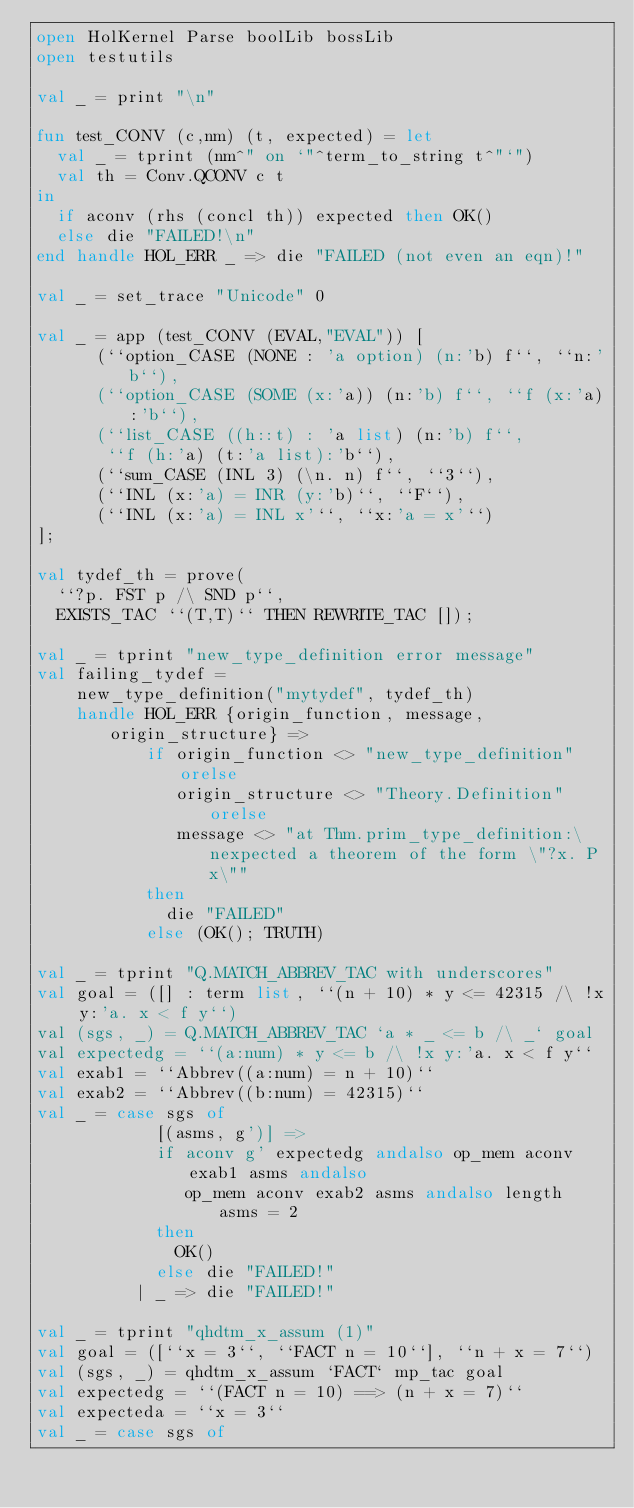<code> <loc_0><loc_0><loc_500><loc_500><_SML_>open HolKernel Parse boolLib bossLib
open testutils

val _ = print "\n"

fun test_CONV (c,nm) (t, expected) = let
  val _ = tprint (nm^" on `"^term_to_string t^"`")
  val th = Conv.QCONV c t
in
  if aconv (rhs (concl th)) expected then OK()
  else die "FAILED!\n"
end handle HOL_ERR _ => die "FAILED (not even an eqn)!"

val _ = set_trace "Unicode" 0

val _ = app (test_CONV (EVAL,"EVAL")) [
      (``option_CASE (NONE : 'a option) (n:'b) f``, ``n:'b``),
      (``option_CASE (SOME (x:'a)) (n:'b) f``, ``f (x:'a):'b``),
      (``list_CASE ((h::t) : 'a list) (n:'b) f``,
       ``f (h:'a) (t:'a list):'b``),
      (``sum_CASE (INL 3) (\n. n) f``, ``3``),
      (``INL (x:'a) = INR (y:'b)``, ``F``),
      (``INL (x:'a) = INL x'``, ``x:'a = x'``)
];

val tydef_th = prove(
  ``?p. FST p /\ SND p``,
  EXISTS_TAC ``(T,T)`` THEN REWRITE_TAC []);

val _ = tprint "new_type_definition error message"
val failing_tydef =
    new_type_definition("mytydef", tydef_th)
    handle HOL_ERR {origin_function, message, origin_structure} =>
           if origin_function <> "new_type_definition" orelse
              origin_structure <> "Theory.Definition" orelse
              message <> "at Thm.prim_type_definition:\nexpected a theorem of the form \"?x. P x\""
           then
             die "FAILED"
           else (OK(); TRUTH)

val _ = tprint "Q.MATCH_ABBREV_TAC with underscores"
val goal = ([] : term list, ``(n + 10) * y <= 42315 /\ !x y:'a. x < f y``)
val (sgs, _) = Q.MATCH_ABBREV_TAC `a * _ <= b /\ _` goal
val expectedg = ``(a:num) * y <= b /\ !x y:'a. x < f y``
val exab1 = ``Abbrev((a:num) = n + 10)``
val exab2 = ``Abbrev((b:num) = 42315)``
val _ = case sgs of
            [(asms, g')] =>
            if aconv g' expectedg andalso op_mem aconv exab1 asms andalso
               op_mem aconv exab2 asms andalso length asms = 2
            then
              OK()
            else die "FAILED!"
          | _ => die "FAILED!"

val _ = tprint "qhdtm_x_assum (1)"
val goal = ([``x = 3``, ``FACT n = 10``], ``n + x = 7``)
val (sgs, _) = qhdtm_x_assum `FACT` mp_tac goal
val expectedg = ``(FACT n = 10) ==> (n + x = 7)``
val expecteda = ``x = 3``
val _ = case sgs of</code> 